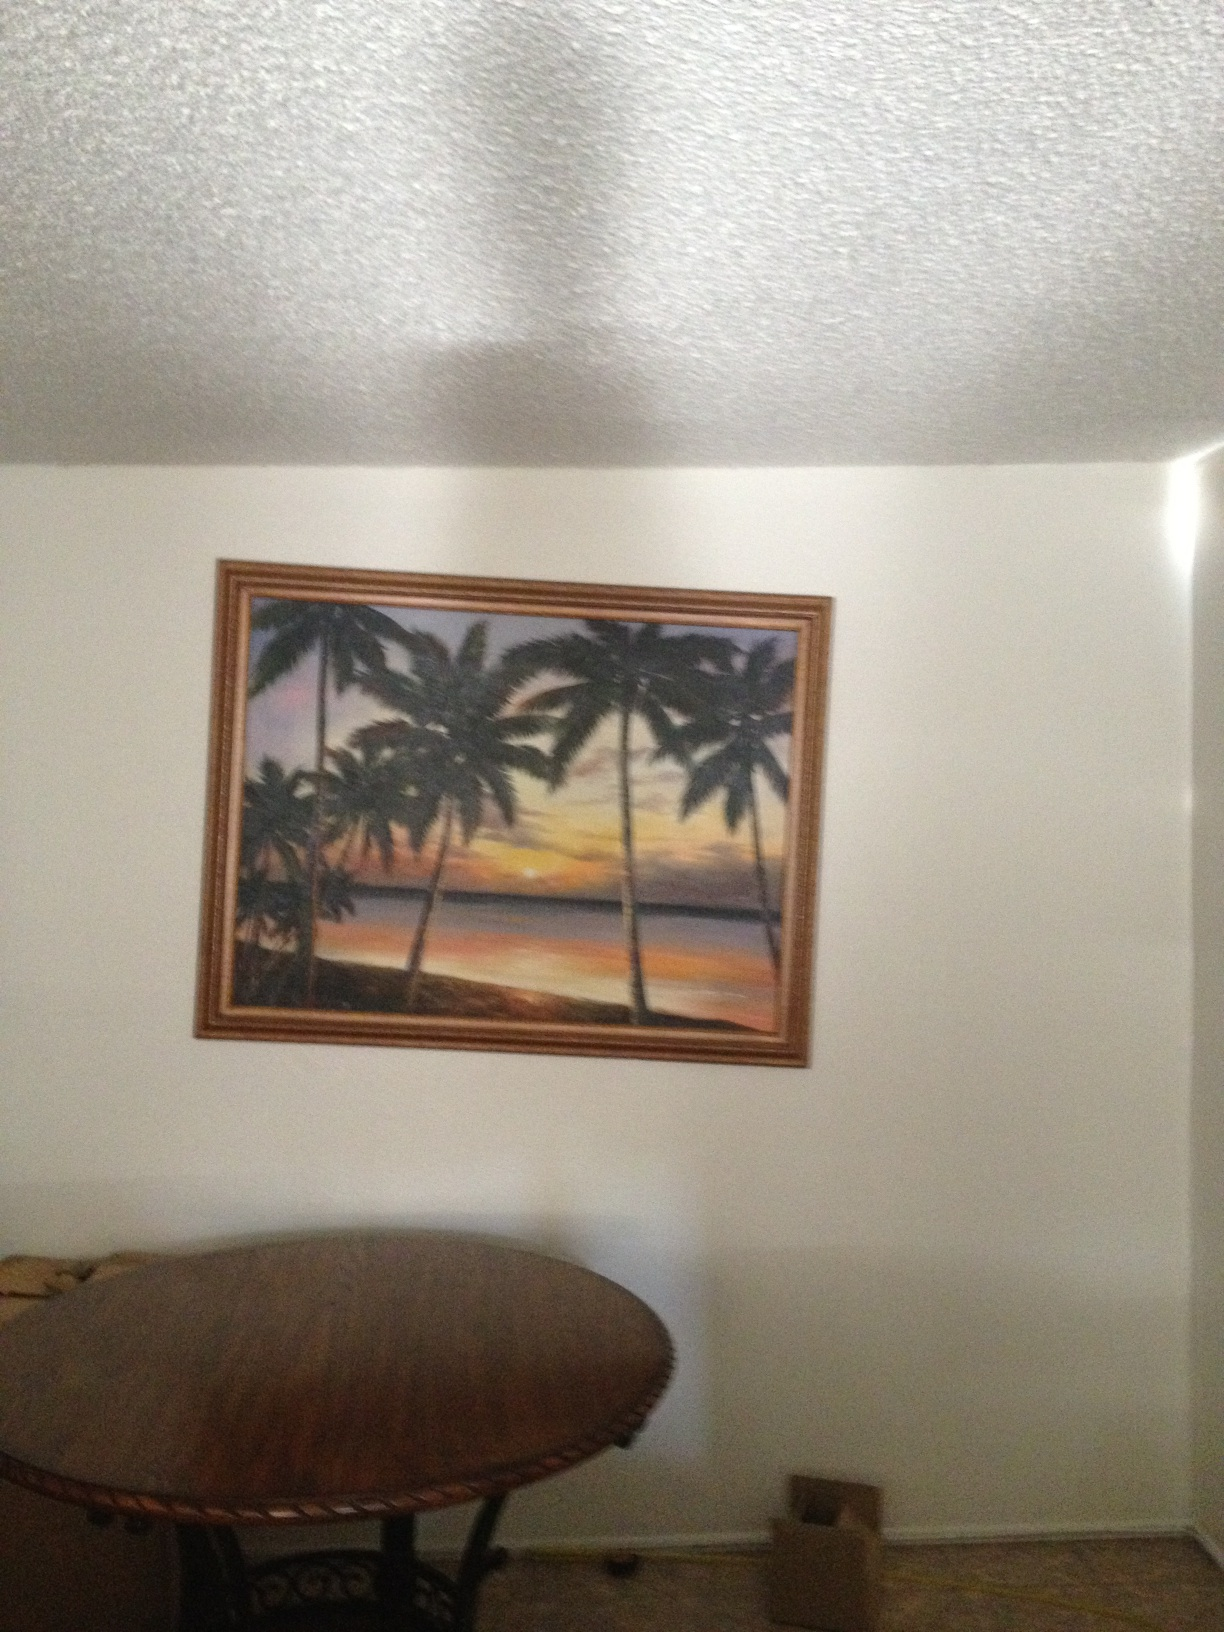What time of day might this painting represent, and what feelings does it evoke in you? The painting likely represents early evening, capturing the serene beauty of a sunset. The vibrant colors and calm seas evoke a sense of peace and tranquility, perhaps a moment of reflection or a soothing escape from the daily routine. 